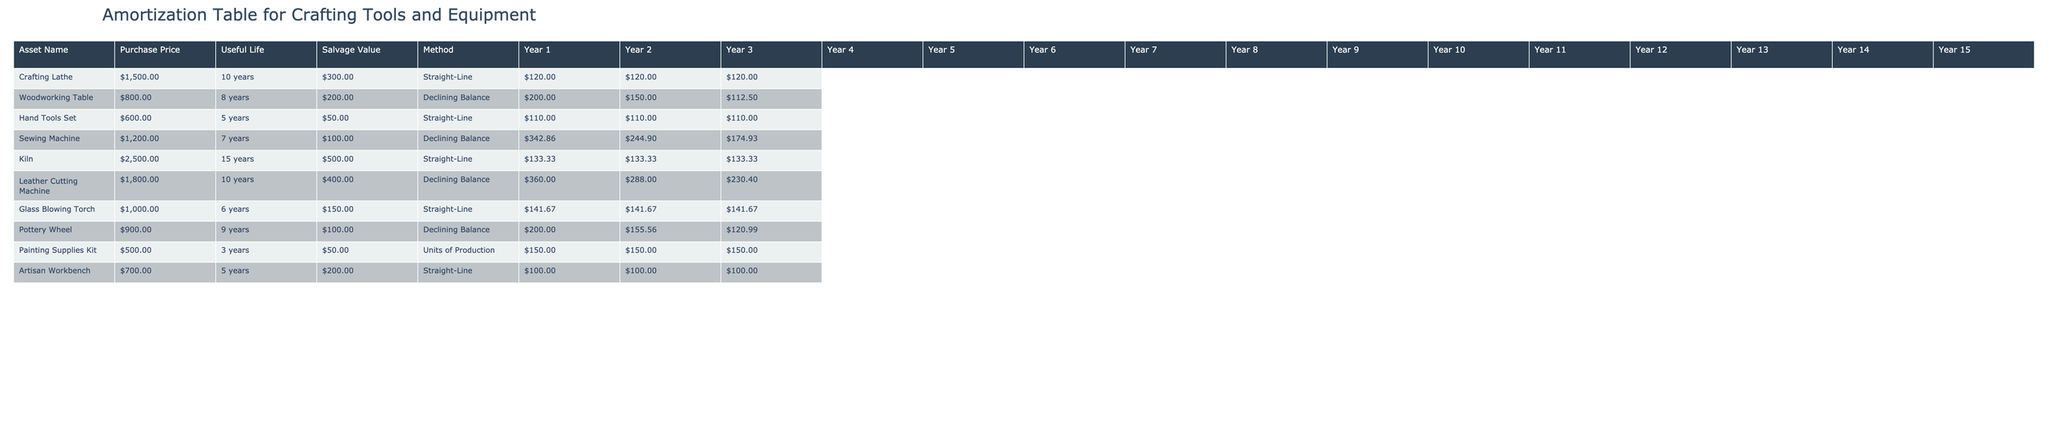What is the purchase price of the Leather Cutting Machine? The purchase price can be found in the table under the 'Purchase Price' column for the 'Leather Cutting Machine' row. It is listed as $1,800.00.
Answer: $1,800.00 What is the salvage value of the Sewing Machine? The salvage value is located in the 'Salvage Value' column corresponding to the 'Sewing Machine' row, which shows $100.00.
Answer: $100.00 Which asset has the longest useful life? To determine this, we look at the 'Useful Life (Years)' column and find the maximum value. The 'Kiln' has the longest useful life of 15 years.
Answer: Kiln What is the total depreciation for the Crafting Lathe over its useful life? The total depreciation can be calculated by summing the annual depreciation for each year based on the 'Straight-Line' method. The annual depreciation is calculated as (Purchase Price - Salvage Value) / Useful Life, which is (1500 - 300) / 10 = $120. The total depreciation over 10 years is 10 * $120 = $1,200.
Answer: $1,200.00 Is the depreciation method for the Hand Tools Set Straight-Line? Referring to the 'Depreciation Method' column, we see that it is indeed 'Straight-Line' for the 'Hand Tools Set'.
Answer: Yes What is the average depreciation expense per year for the Pottery Wheel? The average depreciation expense can be determined by first looking at the total depreciation calculated for the Pottery Wheel using the 'Declining Balance' method over 9 years. The various annual depreciation values are then summed and divided by 9. After calculations, it results in an average of approximately $118.89.
Answer: Approximately $118.89 What is the difference in total depreciation between the Woodworking Table and the Leather Cutting Machine? First, calculate the total depreciation for both assets. The Woodworking Table uses the 'Declining Balance' method, while the Leather Cutting Machine also uses 'Declining Balance'. After performing the calculations for both assets, we find the total depreciation for the Woodworking Table is $728.32 and for the Leather Cutting Machine is $1,440.00. The difference is $1,440 - $728.32 = $711.68.
Answer: $711.68 How many years does the Hand Tools Set have until its salvage value is reached? The salvage value of the Hand Tools Set is $50. The asset depreciates over 5 years, with the depreciation amount degrading its value down to the salvage value. Therefore, it has a total useful life of 5 years before reaching the salvage value.
Answer: 5 Which asset shows the highest annual depreciation in year 1? By inspecting the first year's depreciation values of all assets, the Leather Cutting Machine shows the highest depreciation in year 1, with $360.00 calculated from the Downey Balance method.
Answer: Leather Cutting Machine 